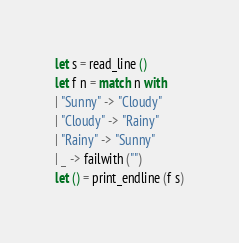Convert code to text. <code><loc_0><loc_0><loc_500><loc_500><_OCaml_>let s = read_line ()
let f n = match n with
| "Sunny" -> "Cloudy"
| "Cloudy" -> "Rainy"
| "Rainy" -> "Sunny"
| _ -> failwith ("")
let () = print_endline (f s)</code> 